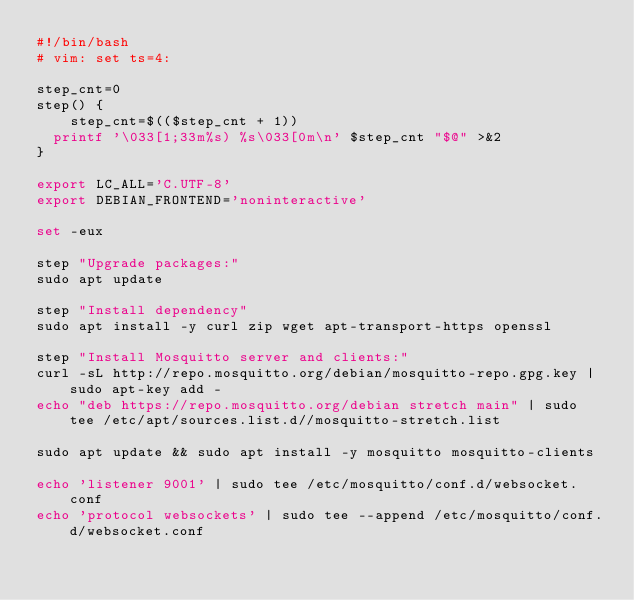Convert code to text. <code><loc_0><loc_0><loc_500><loc_500><_Bash_>#!/bin/bash
# vim: set ts=4:

step_cnt=0
step() {
    step_cnt=$(($step_cnt + 1))
	printf '\033[1;33m%s) %s\033[0m\n' $step_cnt "$@" >&2
}

export LC_ALL='C.UTF-8'
export DEBIAN_FRONTEND='noninteractive'

set -eux

step "Upgrade packages:"
sudo apt update

step "Install dependency"
sudo apt install -y curl zip wget apt-transport-https openssl

step "Install Mosquitto server and clients:"
curl -sL http://repo.mosquitto.org/debian/mosquitto-repo.gpg.key | sudo apt-key add -
echo "deb https://repo.mosquitto.org/debian stretch main" | sudo tee /etc/apt/sources.list.d//mosquitto-stretch.list

sudo apt update && sudo apt install -y mosquitto mosquitto-clients

echo 'listener 9001' | sudo tee /etc/mosquitto/conf.d/websocket.conf
echo 'protocol websockets' | sudo tee --append /etc/mosquitto/conf.d/websocket.conf</code> 